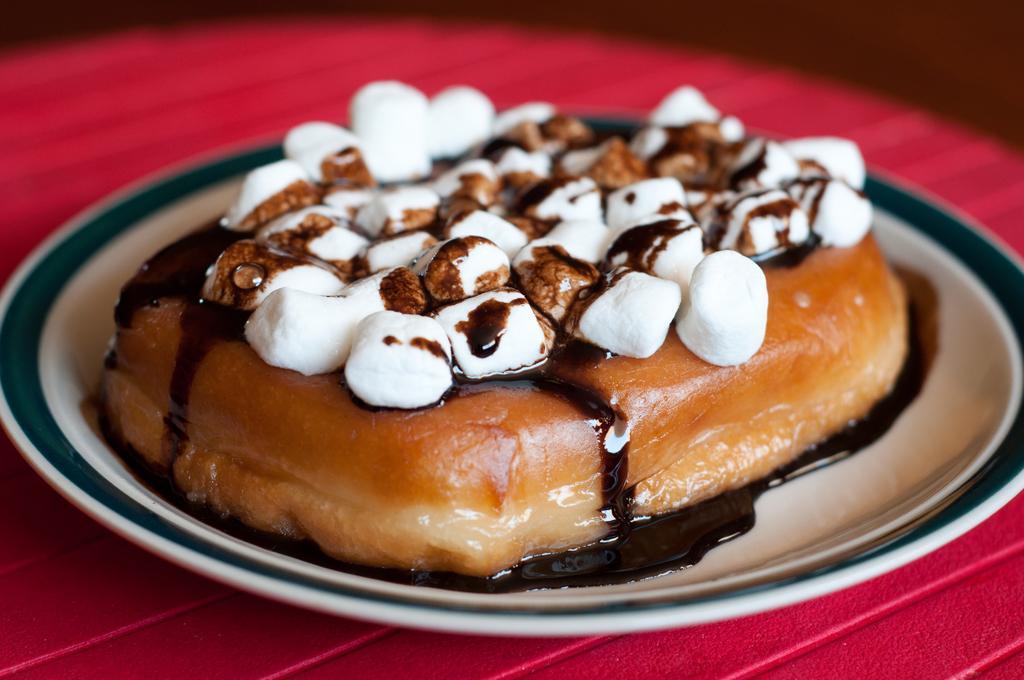Describe this image in one or two sentences. In this image I can see a bread pudding in a plate kept on the table. This image is taken may be in a room. 